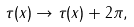<formula> <loc_0><loc_0><loc_500><loc_500>\tau ( x ) \to \tau ( x ) + 2 \pi ,</formula> 